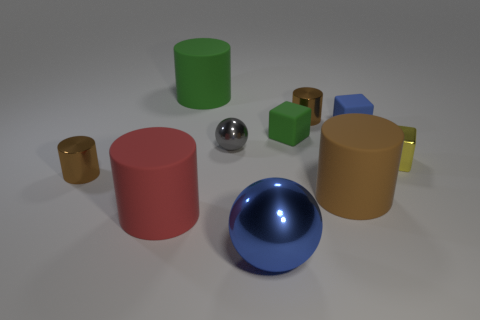There is a small yellow object that is the same shape as the small green matte object; what material is it?
Ensure brevity in your answer.  Metal. There is a tiny rubber object that is on the right side of the brown matte cylinder; is its color the same as the large metallic sphere?
Provide a short and direct response. Yes. Is the material of the small green cube the same as the block in front of the tiny gray shiny ball?
Offer a terse response. No. The big green rubber thing behind the blue sphere has what shape?
Your response must be concise. Cylinder. How big is the yellow metal object?
Provide a short and direct response. Small. What number of other things are the same color as the tiny metal ball?
Offer a terse response. 0. There is a matte object that is both in front of the gray metallic ball and behind the red rubber thing; what is its color?
Keep it short and to the point. Brown. How many rubber cylinders are there?
Your answer should be compact. 3. Does the big sphere have the same material as the yellow block?
Offer a very short reply. Yes. There is a metallic object that is on the right side of the tiny brown shiny cylinder that is right of the ball that is in front of the metal block; what is its shape?
Make the answer very short. Cube. 